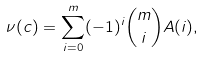Convert formula to latex. <formula><loc_0><loc_0><loc_500><loc_500>\nu ( c ) = \sum _ { i = 0 } ^ { m } ( - 1 ) ^ { i } { m \choose i } A ( i ) ,</formula> 